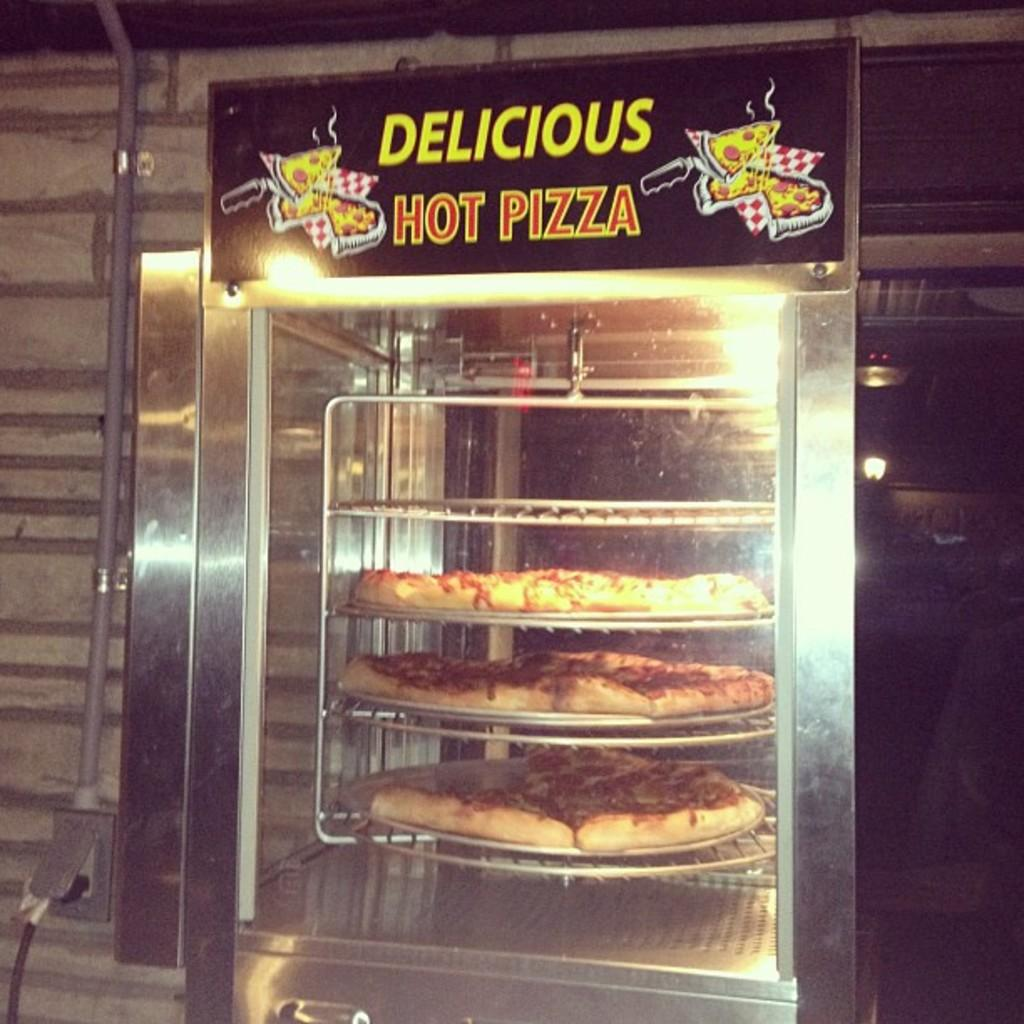What is being cooked in the pizza oven in the image? There are pizzas in a pizza oven in the image. Is there any identification or labeling on the pizza oven? Yes, there is a name board on the pizza oven. What can be seen in the background of the image? There is a wall visible in the background of the image, and there are objects present in the background as well. How many icicles are hanging from the pizza oven in the image? There are no icicles present in the image, as it is not a cold environment where icicles would form. 